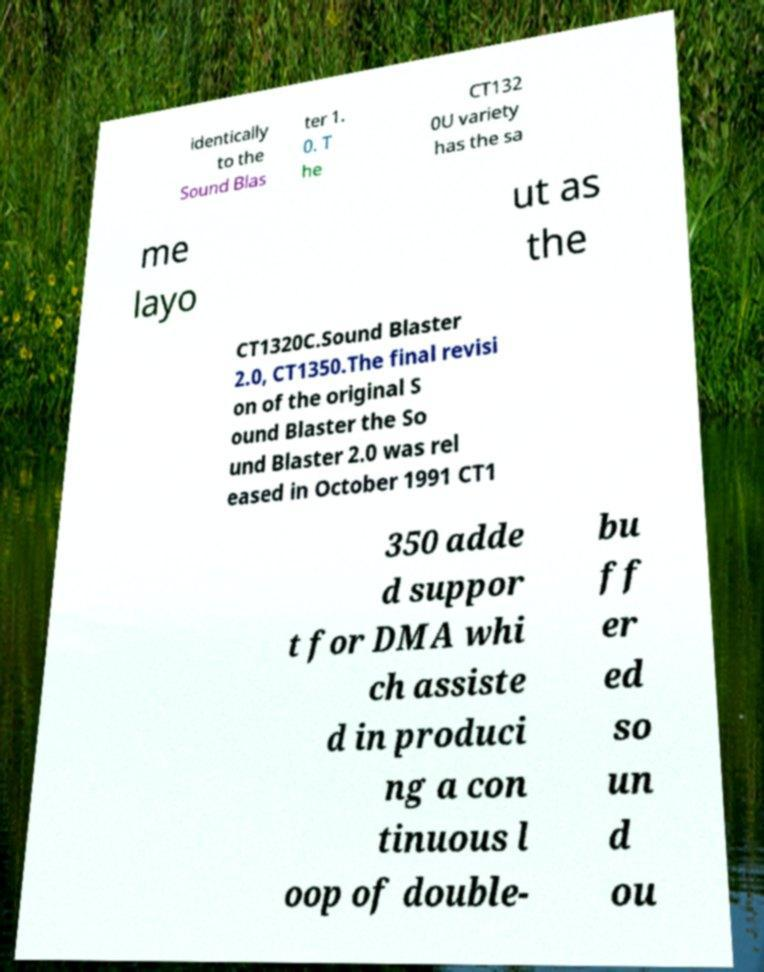Please identify and transcribe the text found in this image. identically to the Sound Blas ter 1. 0. T he CT132 0U variety has the sa me layo ut as the CT1320C.Sound Blaster 2.0, CT1350.The final revisi on of the original S ound Blaster the So und Blaster 2.0 was rel eased in October 1991 CT1 350 adde d suppor t for DMA whi ch assiste d in produci ng a con tinuous l oop of double- bu ff er ed so un d ou 